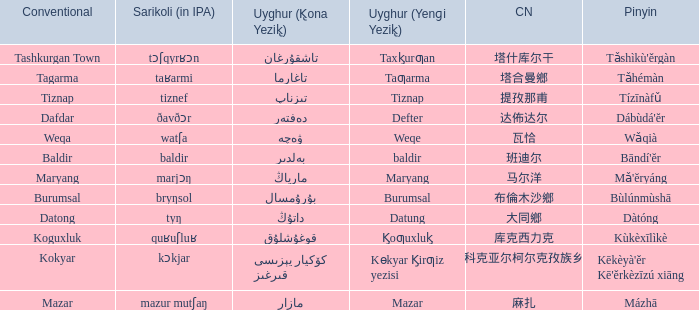Name the pinyin for  kɵkyar k̡irƣiz yezisi Kēkèyà'ěr Kē'ěrkèzīzú xiāng. Could you parse the entire table? {'header': ['Conventional', 'Sarikoli (in IPA)', 'Uyghur (K̢ona Yezik̢)', 'Uyghur (Yenɡi Yezik̢)', 'CN', 'Pinyin'], 'rows': [['Tashkurgan Town', 'tɔʃqyrʁɔn', 'تاشقۇرغان', 'Taxk̡urƣan', '塔什库尔干', "Tǎshìkù'ěrgàn"], ['Tagarma', 'taʁarmi', 'تاغارما', 'Taƣarma', '塔合曼鄉', 'Tǎhémàn'], ['Tiznap', 'tiznef', 'تىزناپ', 'Tiznap', '提孜那甫', 'Tízīnàfǔ'], ['Dafdar', 'ðavðɔr', 'دەفتەر', 'Defter', '达佈达尔', "Dábùdá'ĕr"], ['Weqa', 'watʃa', 'ۋەچە', 'Weqe', '瓦恰', 'Wǎqià'], ['Baldir', 'baldir', 'بەلدىر', 'baldir', '班迪尔', "Bāndí'ĕr"], ['Maryang', 'marjɔŋ', 'مارياڭ', 'Maryang', '马尔洋', "Mǎ'ĕryáng"], ['Burumsal', 'bryŋsol', 'بۇرۇمسال', 'Burumsal', '布倫木沙鄉', 'Bùlúnmùshā'], ['Datong', 'tyŋ', 'داتۇڭ', 'Datung', '大同鄉', 'Dàtóng'], ['Koguxluk', 'quʁuʃluʁ', 'قوغۇشلۇق', 'K̡oƣuxluk̡', '库克西力克', 'Kùkèxīlìkè'], ['Kokyar', 'kɔkjar', 'كۆكيار قىرغىز يېزىسى', 'Kɵkyar K̡irƣiz yezisi', '科克亚尔柯尔克孜族乡', "Kēkèyà'ěr Kē'ěrkèzīzú xiāng"], ['Mazar', 'mazur mutʃaŋ', 'مازار', 'Mazar', '麻扎', 'Mázhā']]} 